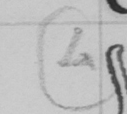What text is written in this handwritten line? ( 4 